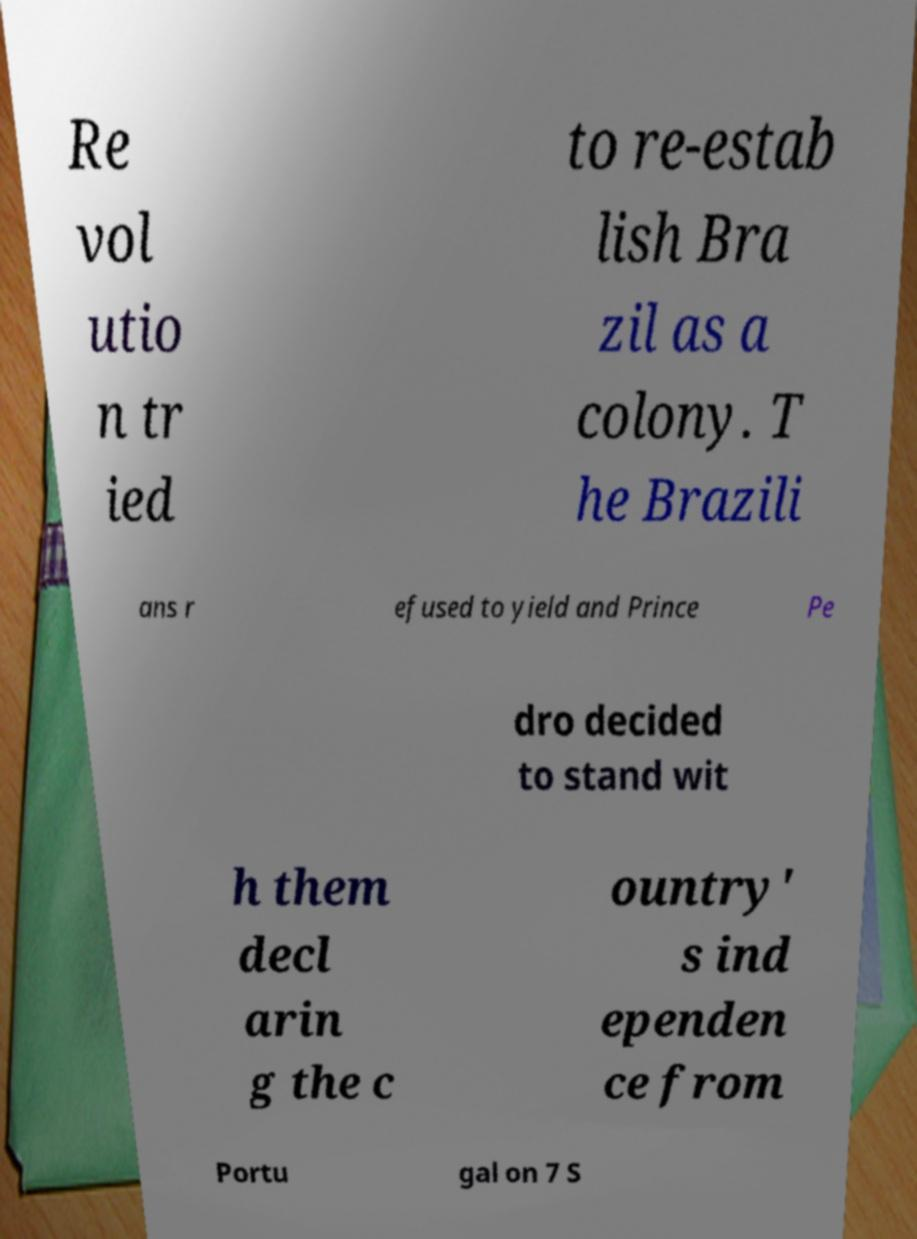For documentation purposes, I need the text within this image transcribed. Could you provide that? Re vol utio n tr ied to re-estab lish Bra zil as a colony. T he Brazili ans r efused to yield and Prince Pe dro decided to stand wit h them decl arin g the c ountry' s ind ependen ce from Portu gal on 7 S 